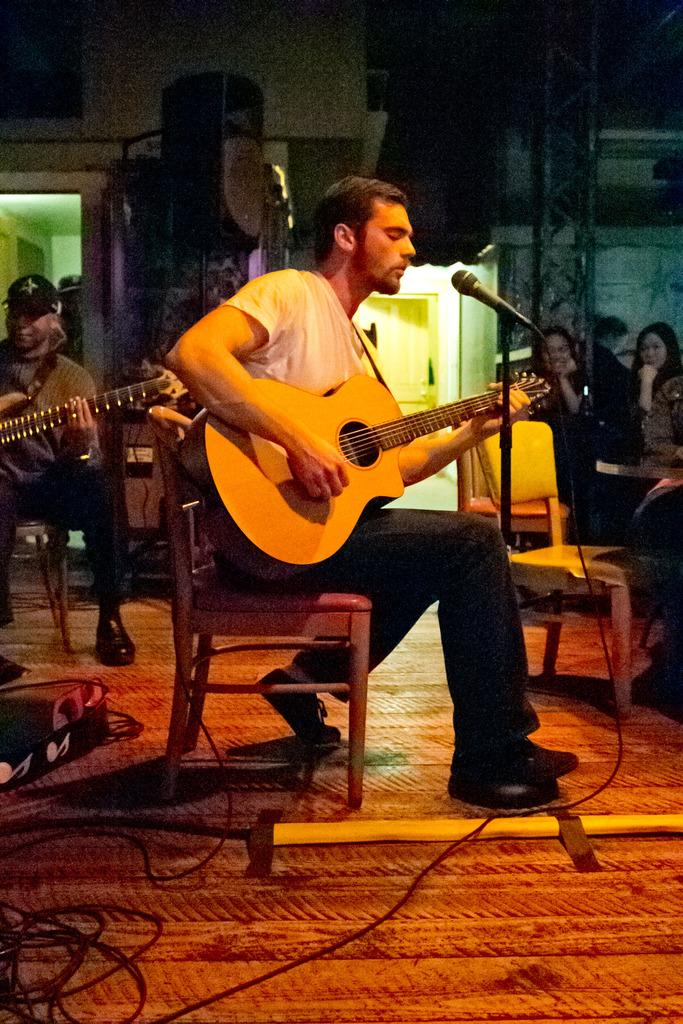What is the man in the image doing? The man in the image is playing a guitar. How many women are sitting in the image? There are two women sitting on chairs in the image. What is the other man in the image doing? The other man in the image is also playing a guitar. What type of pump is being used by the man playing the guitar? There is no pump present in the image; the man is playing a guitar. What authority does the woman sitting on the chair have in the image? There is no indication of authority in the image; the women are simply sitting on chairs. 